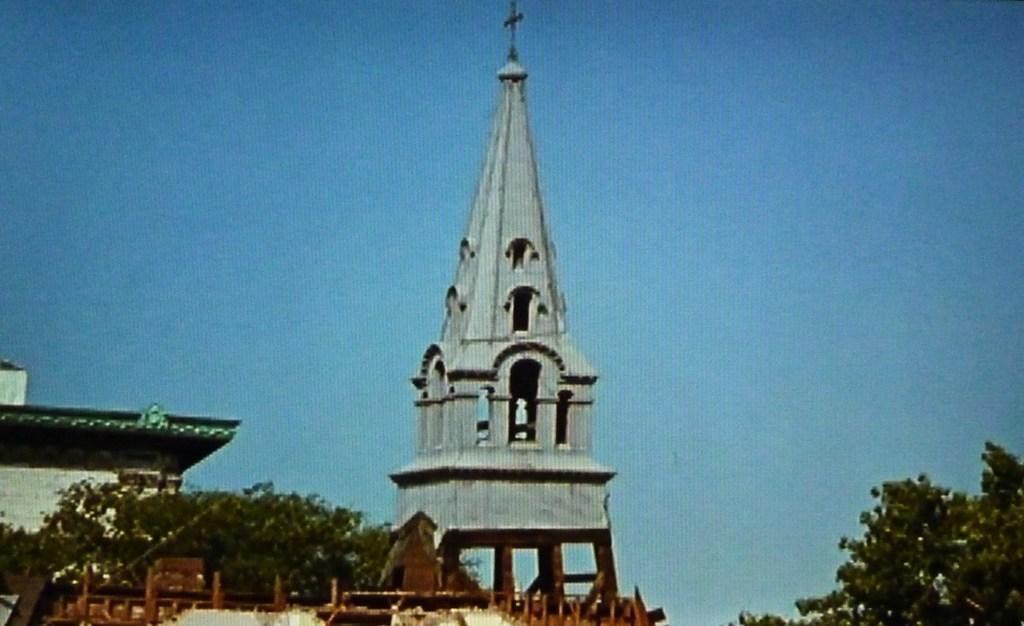In one or two sentences, can you explain what this image depicts? In this picture we can see a church with holy cross on the top of it. This a blue sky on the background. This is a house. Here we can see trees. 